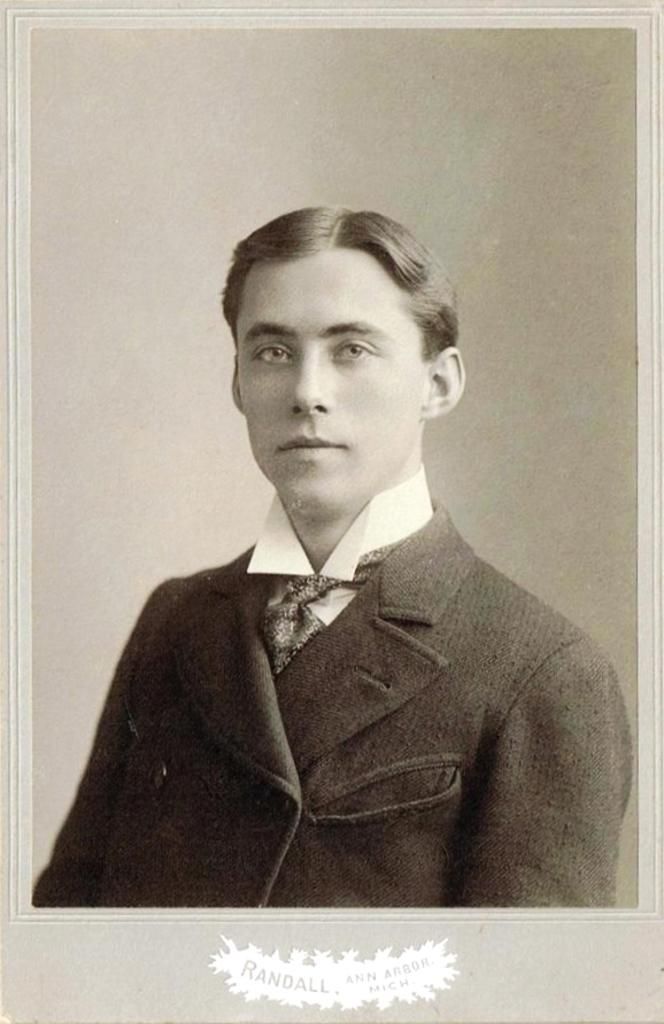What is the main subject of the image? There is a person in the image. What is the color scheme of the image? The image is in black and white. What type of furniture is visible in the image? There is no furniture visible in the image; it only features a person. Can you describe the kitty walking in the image? There is no kitty present in the image. 